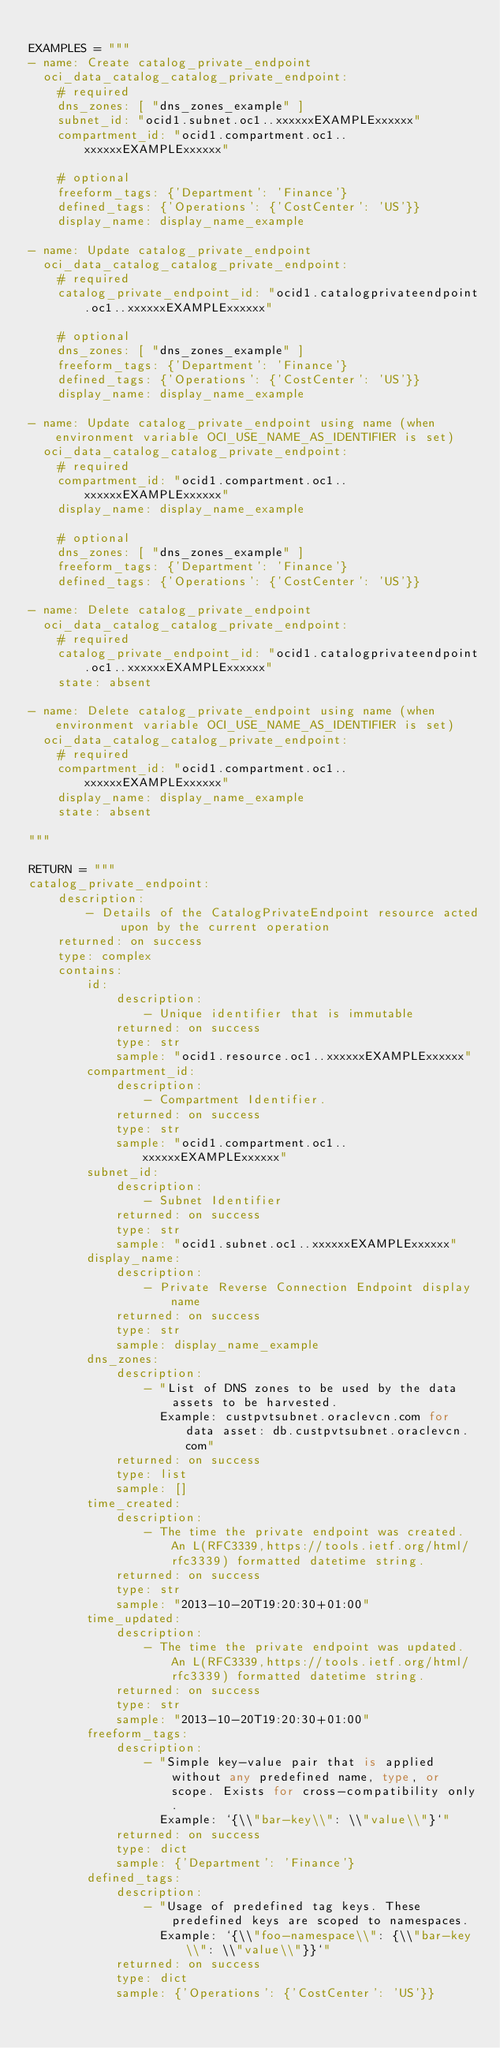Convert code to text. <code><loc_0><loc_0><loc_500><loc_500><_Python_>
EXAMPLES = """
- name: Create catalog_private_endpoint
  oci_data_catalog_catalog_private_endpoint:
    # required
    dns_zones: [ "dns_zones_example" ]
    subnet_id: "ocid1.subnet.oc1..xxxxxxEXAMPLExxxxxx"
    compartment_id: "ocid1.compartment.oc1..xxxxxxEXAMPLExxxxxx"

    # optional
    freeform_tags: {'Department': 'Finance'}
    defined_tags: {'Operations': {'CostCenter': 'US'}}
    display_name: display_name_example

- name: Update catalog_private_endpoint
  oci_data_catalog_catalog_private_endpoint:
    # required
    catalog_private_endpoint_id: "ocid1.catalogprivateendpoint.oc1..xxxxxxEXAMPLExxxxxx"

    # optional
    dns_zones: [ "dns_zones_example" ]
    freeform_tags: {'Department': 'Finance'}
    defined_tags: {'Operations': {'CostCenter': 'US'}}
    display_name: display_name_example

- name: Update catalog_private_endpoint using name (when environment variable OCI_USE_NAME_AS_IDENTIFIER is set)
  oci_data_catalog_catalog_private_endpoint:
    # required
    compartment_id: "ocid1.compartment.oc1..xxxxxxEXAMPLExxxxxx"
    display_name: display_name_example

    # optional
    dns_zones: [ "dns_zones_example" ]
    freeform_tags: {'Department': 'Finance'}
    defined_tags: {'Operations': {'CostCenter': 'US'}}

- name: Delete catalog_private_endpoint
  oci_data_catalog_catalog_private_endpoint:
    # required
    catalog_private_endpoint_id: "ocid1.catalogprivateendpoint.oc1..xxxxxxEXAMPLExxxxxx"
    state: absent

- name: Delete catalog_private_endpoint using name (when environment variable OCI_USE_NAME_AS_IDENTIFIER is set)
  oci_data_catalog_catalog_private_endpoint:
    # required
    compartment_id: "ocid1.compartment.oc1..xxxxxxEXAMPLExxxxxx"
    display_name: display_name_example
    state: absent

"""

RETURN = """
catalog_private_endpoint:
    description:
        - Details of the CatalogPrivateEndpoint resource acted upon by the current operation
    returned: on success
    type: complex
    contains:
        id:
            description:
                - Unique identifier that is immutable
            returned: on success
            type: str
            sample: "ocid1.resource.oc1..xxxxxxEXAMPLExxxxxx"
        compartment_id:
            description:
                - Compartment Identifier.
            returned: on success
            type: str
            sample: "ocid1.compartment.oc1..xxxxxxEXAMPLExxxxxx"
        subnet_id:
            description:
                - Subnet Identifier
            returned: on success
            type: str
            sample: "ocid1.subnet.oc1..xxxxxxEXAMPLExxxxxx"
        display_name:
            description:
                - Private Reverse Connection Endpoint display name
            returned: on success
            type: str
            sample: display_name_example
        dns_zones:
            description:
                - "List of DNS zones to be used by the data assets to be harvested.
                  Example: custpvtsubnet.oraclevcn.com for data asset: db.custpvtsubnet.oraclevcn.com"
            returned: on success
            type: list
            sample: []
        time_created:
            description:
                - The time the private endpoint was created. An L(RFC3339,https://tools.ietf.org/html/rfc3339) formatted datetime string.
            returned: on success
            type: str
            sample: "2013-10-20T19:20:30+01:00"
        time_updated:
            description:
                - The time the private endpoint was updated. An L(RFC3339,https://tools.ietf.org/html/rfc3339) formatted datetime string.
            returned: on success
            type: str
            sample: "2013-10-20T19:20:30+01:00"
        freeform_tags:
            description:
                - "Simple key-value pair that is applied without any predefined name, type, or scope. Exists for cross-compatibility only.
                  Example: `{\\"bar-key\\": \\"value\\"}`"
            returned: on success
            type: dict
            sample: {'Department': 'Finance'}
        defined_tags:
            description:
                - "Usage of predefined tag keys. These predefined keys are scoped to namespaces.
                  Example: `{\\"foo-namespace\\": {\\"bar-key\\": \\"value\\"}}`"
            returned: on success
            type: dict
            sample: {'Operations': {'CostCenter': 'US'}}</code> 